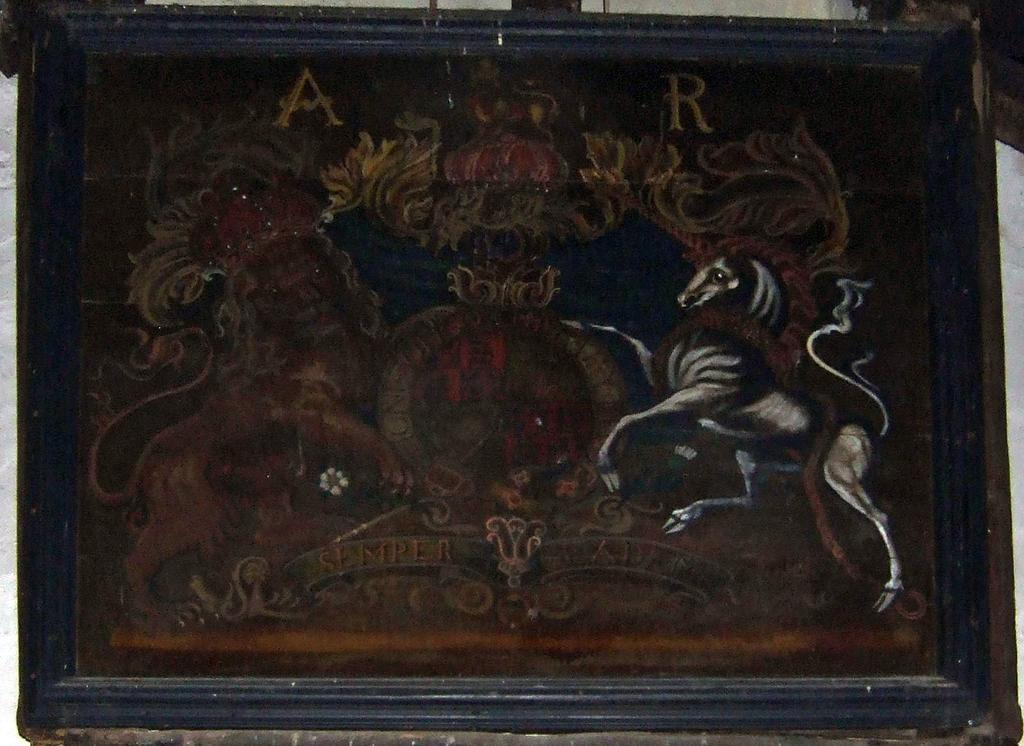What is hanging on the wall in the image? There is a photo frame on the wall. What is depicted in the photo inside the frame? The photo contains drawings of animals and designs. Can you identify any specific elements within the photo? Yes, there are two alphabets visible in the photo. What type of industry can be seen in the background of the photo? There is no industry visible in the image, as the photo contains drawings of animals and designs. How many feet are visible in the photo? There are no feet depicted in the photo, as it contains drawings of animals and designs. 